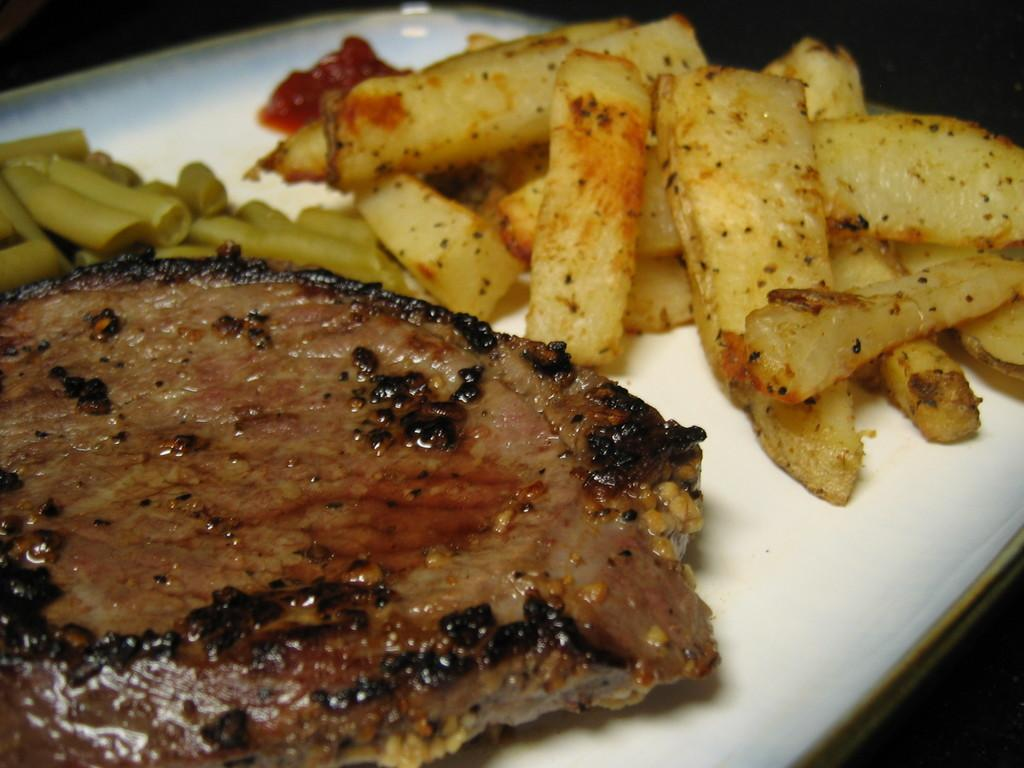What type of objects can be seen in the image? There are food items in the image. How are the food items arranged or presented? The food items are on a white platter. Where is the platter located in the image? The platter is in the foreground of the image. What type of plant can be seen growing in the scene? There is no plant visible in the image; it only features food items on a white platter. How many goats are present in the scene? There are no goats present in the image. 